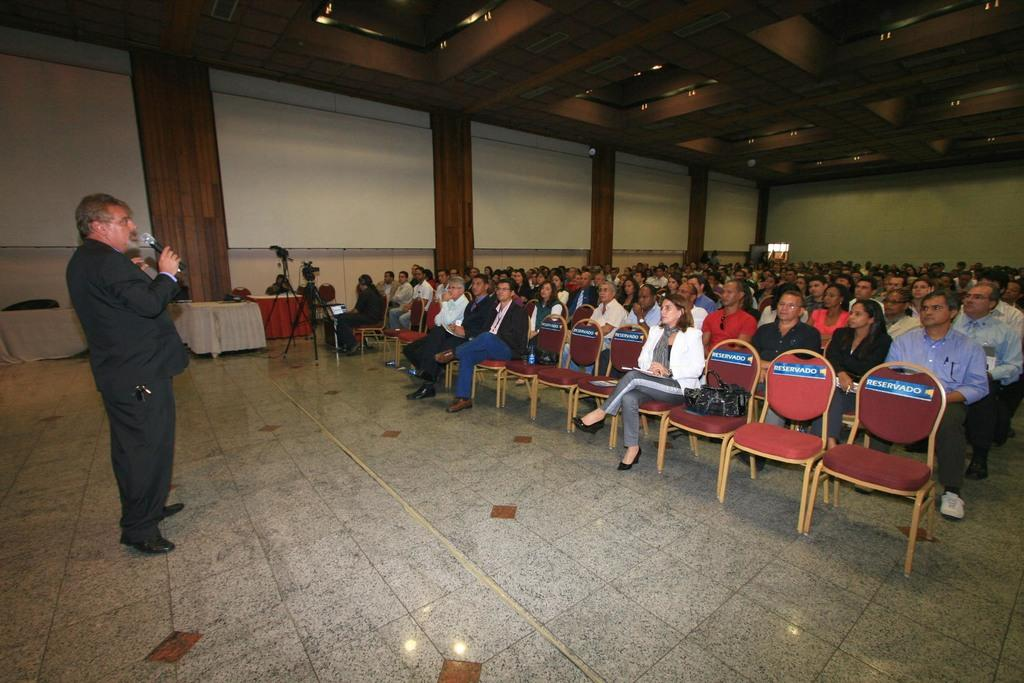What are the people in the image doing? People are sitting on chairs in the image. Can you describe the person who is standing? The person who is standing is holding a microphone. What is the purpose of the table in the image? The table's purpose is not specified, but it is likely being used for support or as a surface for objects. What is the color of the wall in the image? The wall is white in color. What is the name of the owner of the microphone in the image? There is no information about the owner of the microphone in the image, as it only shows a person holding it. Can you describe the journey the person with the microphone is taking in the image? There is no journey depicted in the image; it only shows a person standing and holding a microphone. 